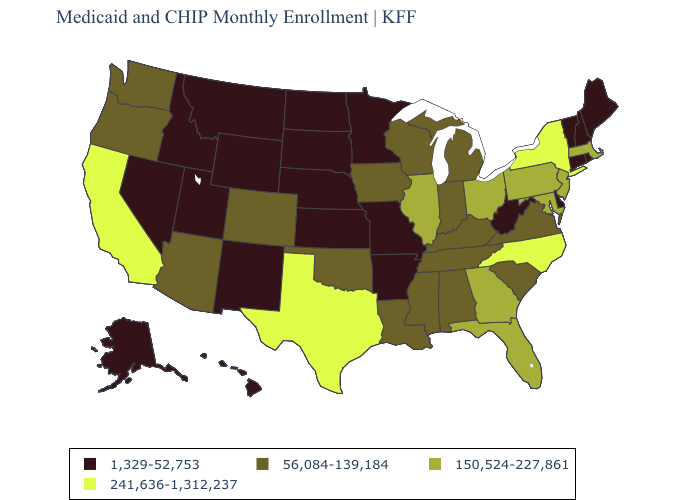Name the states that have a value in the range 241,636-1,312,237?
Write a very short answer. California, New York, North Carolina, Texas. What is the value of Wyoming?
Keep it brief. 1,329-52,753. Which states have the lowest value in the West?
Answer briefly. Alaska, Hawaii, Idaho, Montana, Nevada, New Mexico, Utah, Wyoming. What is the highest value in the Northeast ?
Be succinct. 241,636-1,312,237. Does Missouri have the same value as Alaska?
Keep it brief. Yes. What is the value of Connecticut?
Be succinct. 1,329-52,753. Name the states that have a value in the range 56,084-139,184?
Be succinct. Alabama, Arizona, Colorado, Indiana, Iowa, Kentucky, Louisiana, Michigan, Mississippi, Oklahoma, Oregon, South Carolina, Tennessee, Virginia, Washington, Wisconsin. What is the value of New Jersey?
Answer briefly. 150,524-227,861. Does Nebraska have the highest value in the MidWest?
Concise answer only. No. What is the value of Nebraska?
Write a very short answer. 1,329-52,753. What is the value of California?
Quick response, please. 241,636-1,312,237. How many symbols are there in the legend?
Keep it brief. 4. Which states have the lowest value in the MidWest?
Give a very brief answer. Kansas, Minnesota, Missouri, Nebraska, North Dakota, South Dakota. Does California have the lowest value in the USA?
Short answer required. No. Which states have the lowest value in the South?
Write a very short answer. Arkansas, Delaware, West Virginia. 